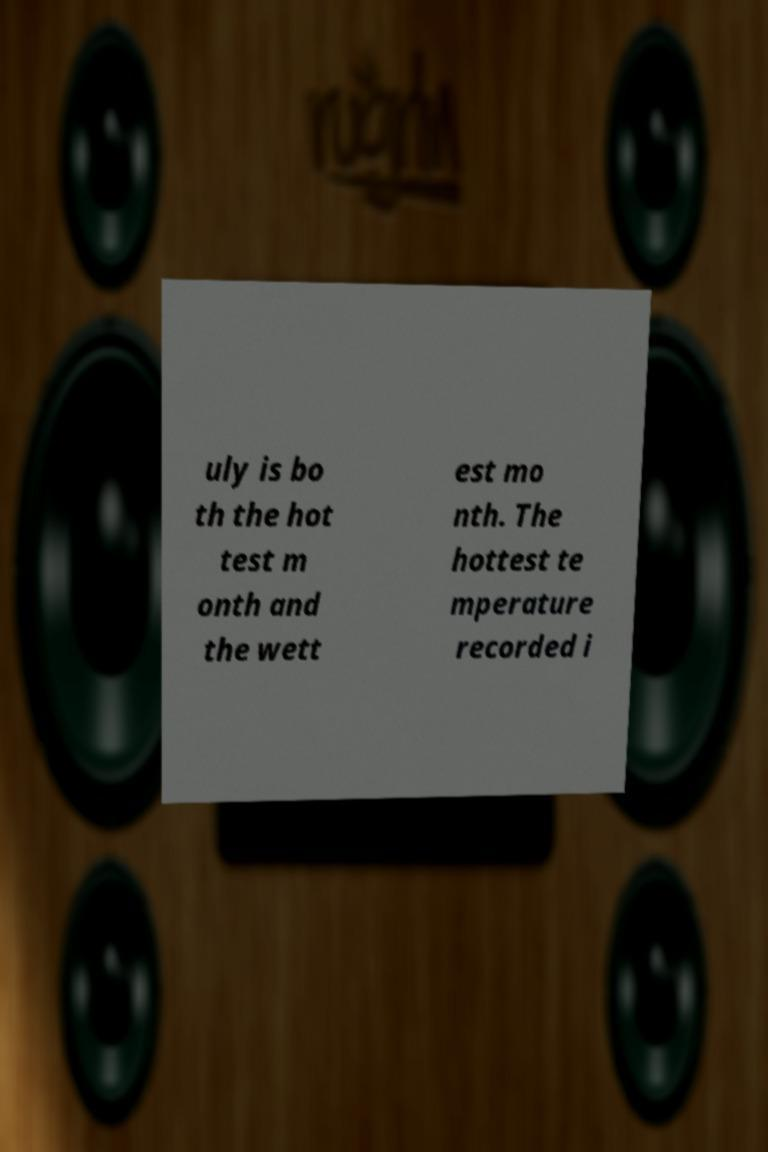Please identify and transcribe the text found in this image. uly is bo th the hot test m onth and the wett est mo nth. The hottest te mperature recorded i 